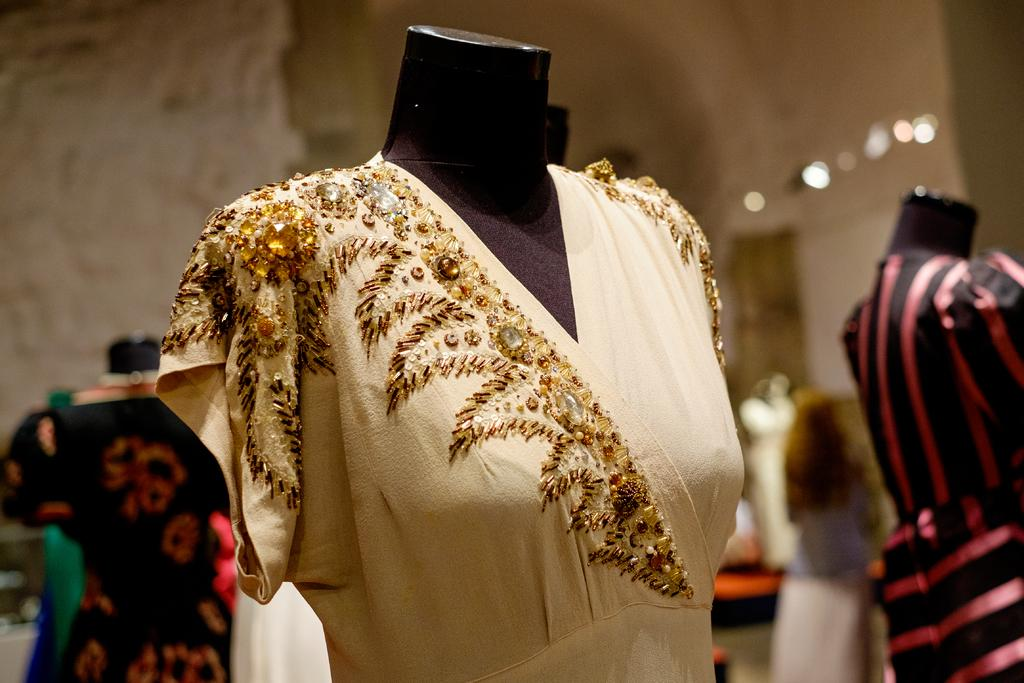What can be seen in the image? There are mannequins in the image. How are the mannequins dressed? The mannequins are dressed. What can be seen in the background of the image? There are lights and some objects in the background of the image. How would you describe the quality of the image? The image is blurry. Is there a body of water visible in the image? No, there is no body of water visible in the image. What type of ray is present in the image? There is no ray present in the image. 